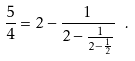Convert formula to latex. <formula><loc_0><loc_0><loc_500><loc_500>\frac { 5 } { 4 } = 2 - \frac { 1 } { 2 - \frac { 1 } { 2 - \frac { 1 } { 2 } } } \ .</formula> 